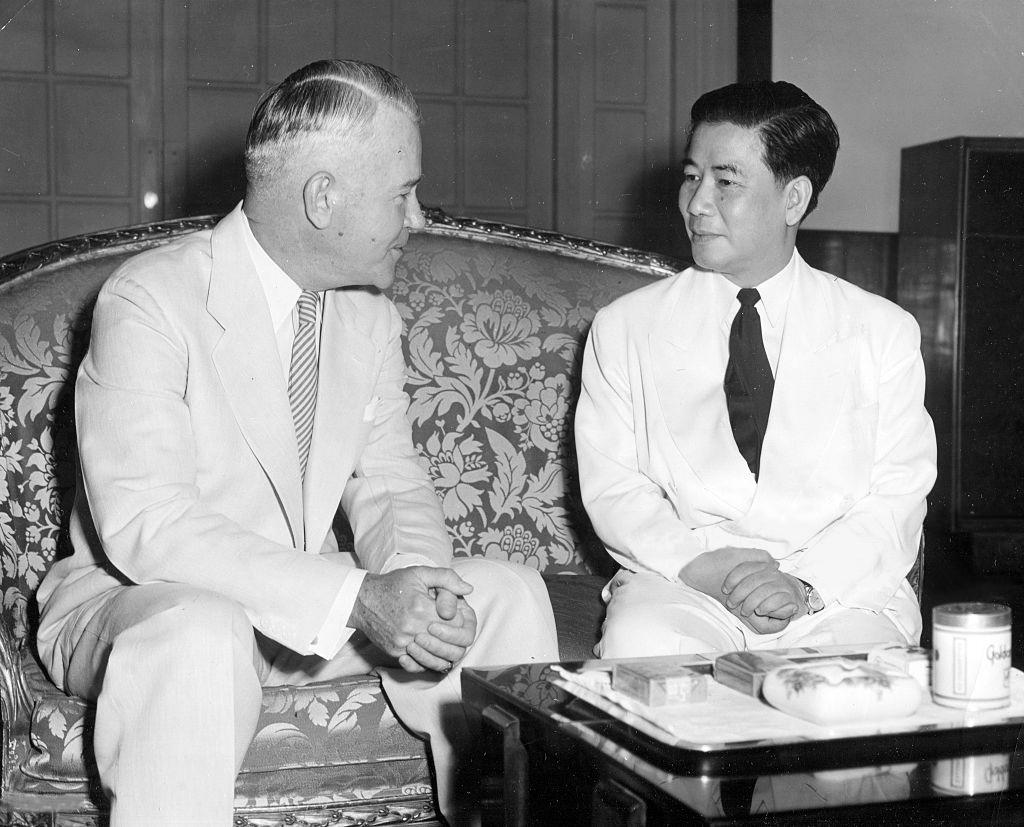How many people are in the image? There are two men in the image. What are the men doing in the image? The men are sitting on a couch. What is present in the image besides the men? There is a table in the image. What can be found on the table? There are objects on the table. What type of crime is being committed in the image? There is no indication of a crime being committed in the image. What is being served for lunch in the image? The facts provided do not mention any food or lunch being served in the image. 